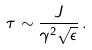<formula> <loc_0><loc_0><loc_500><loc_500>\tau \sim \frac { J } { \gamma ^ { 2 } \sqrt { \epsilon } } \, .</formula> 